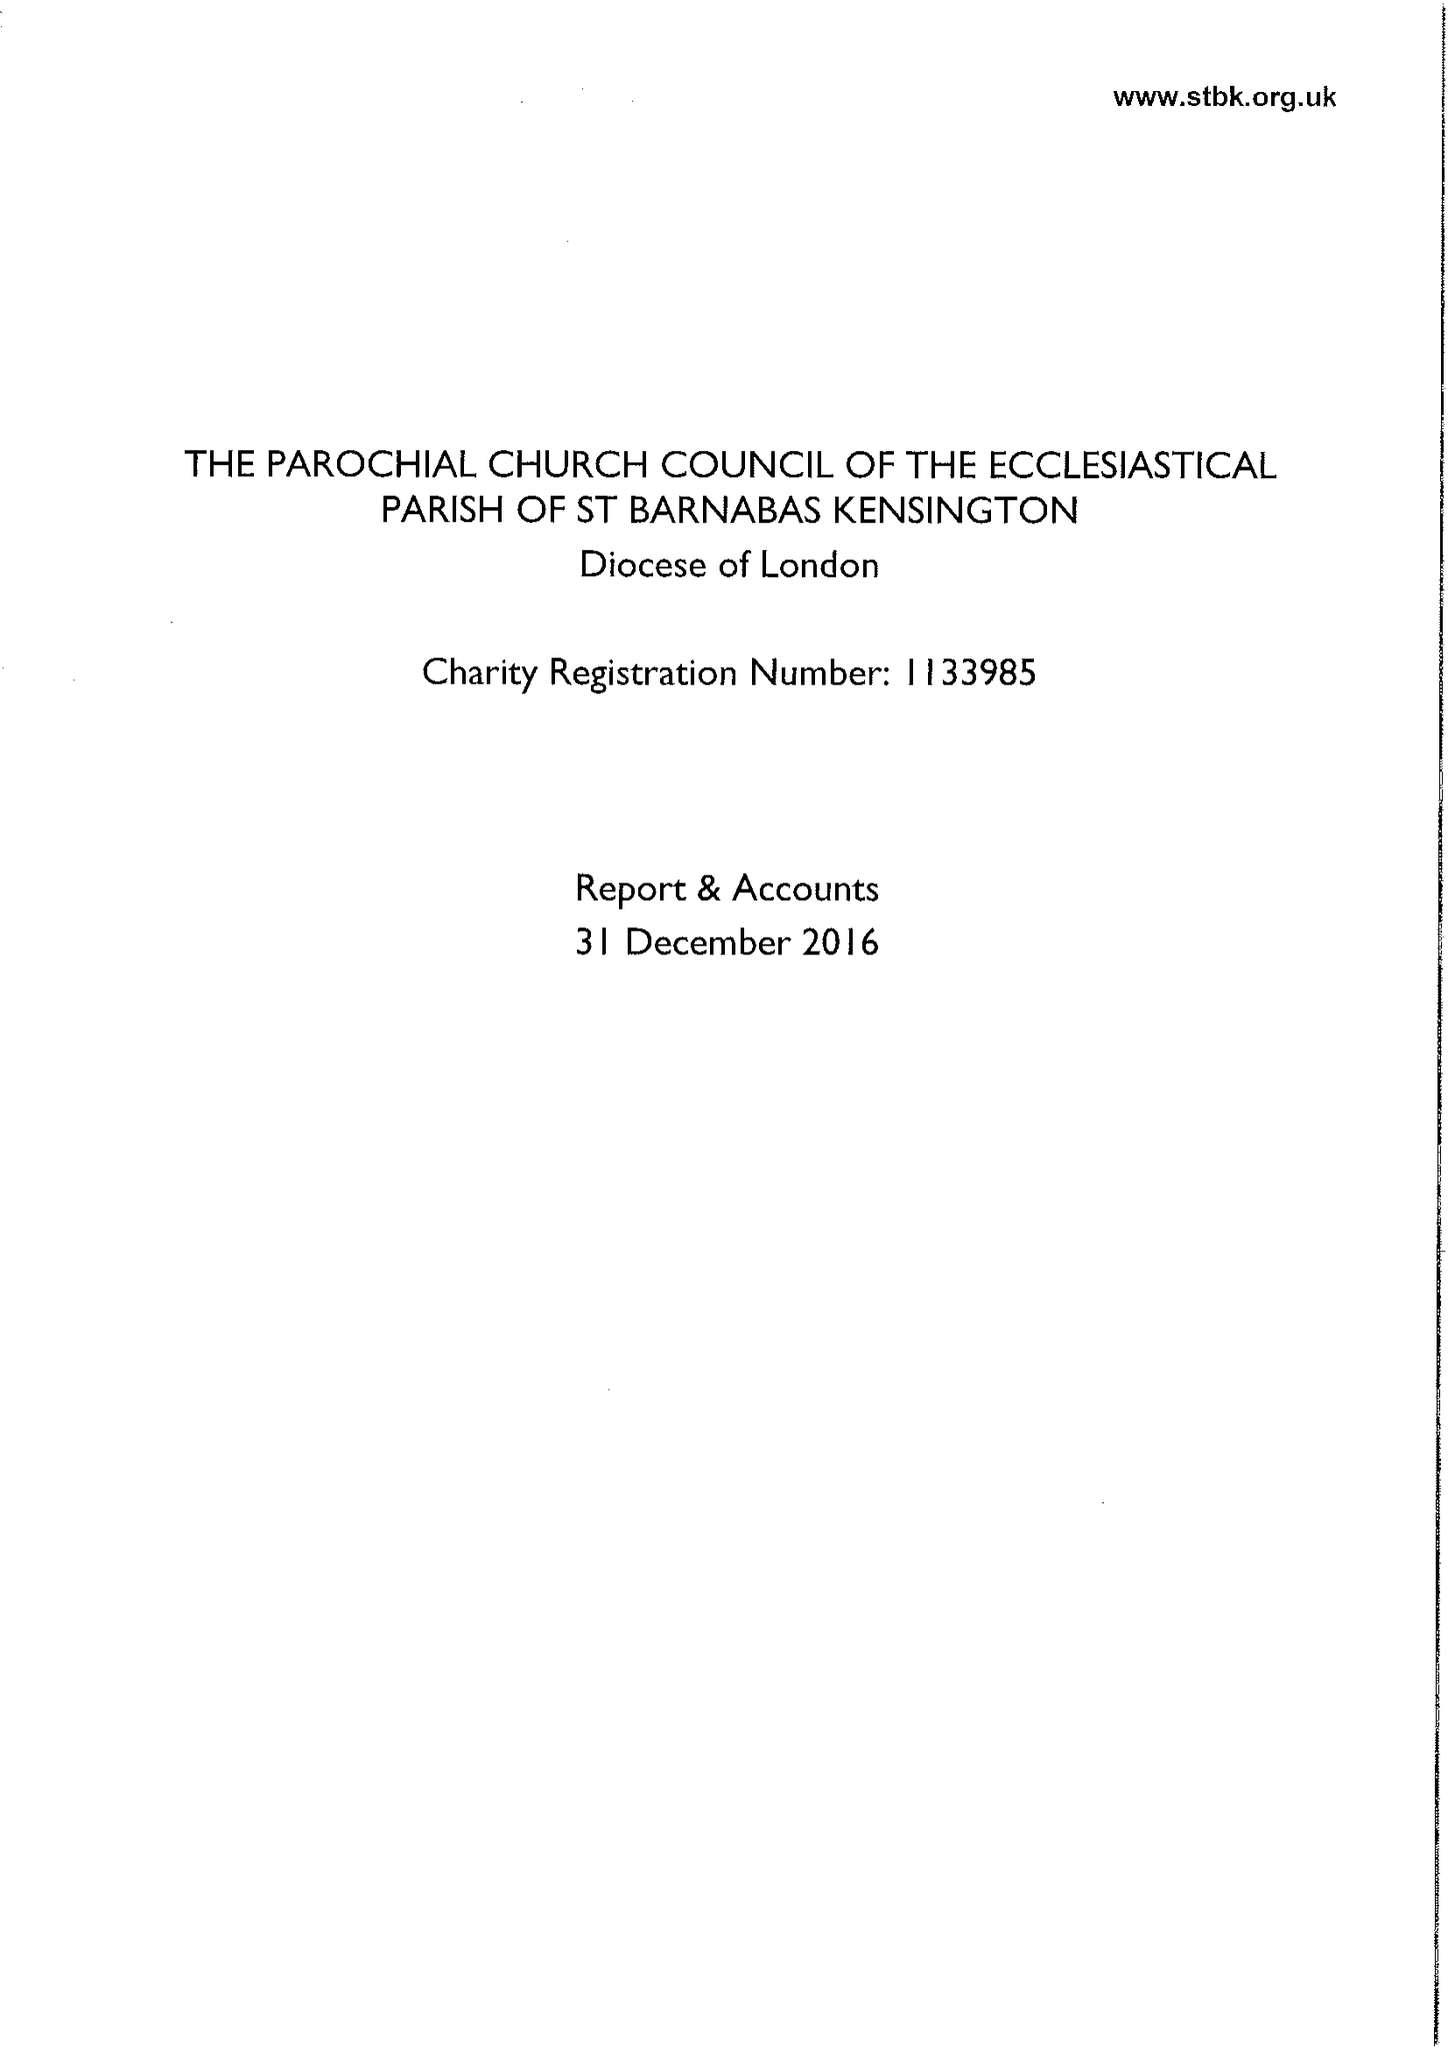What is the value for the address__post_town?
Answer the question using a single word or phrase. LONDON 